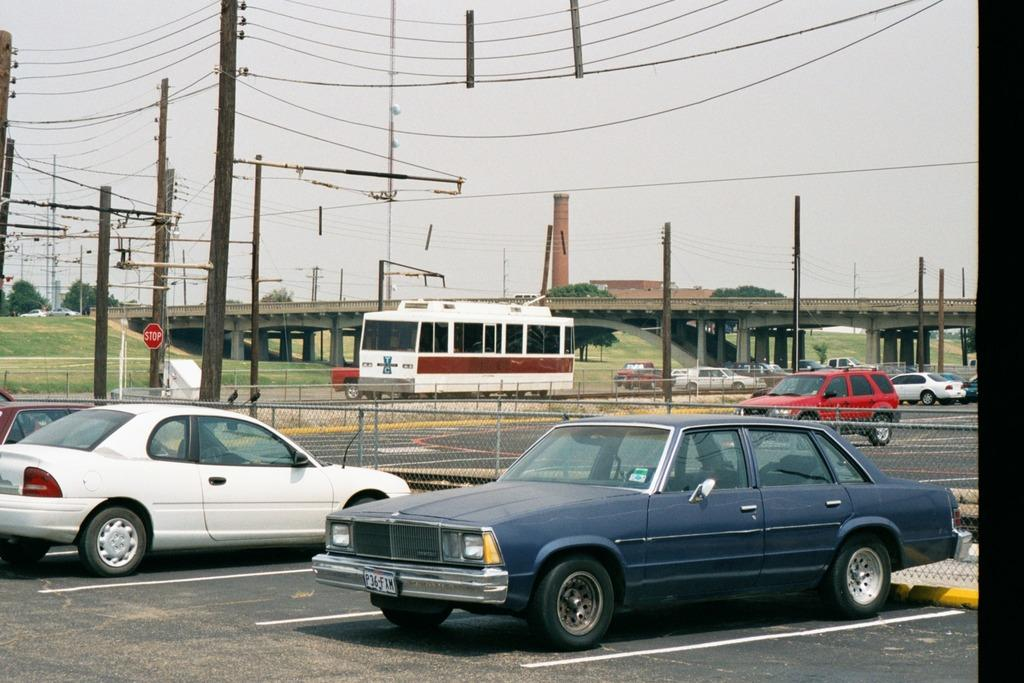What can be seen on the road in the image? There are vehicles on the road in the image. What structure is visible in the background of the image? There is a bridge in the background of the image. What else can be seen in the background of the image? There are poles with wires in the background of the image. What type of barrier is present in the image? There is a fence in the image. What is visible at the top of the image? The sky is visible at the top of the image. What type of bit is used for the discovery in the image? There is no mention of a bit or a discovery in the image; it features vehicles on the road, a bridge, poles with wires, a fence, and the sky. What is the profit made from the vehicles in the image? There is no information about profit or financial transactions related to the vehicles in the image. 